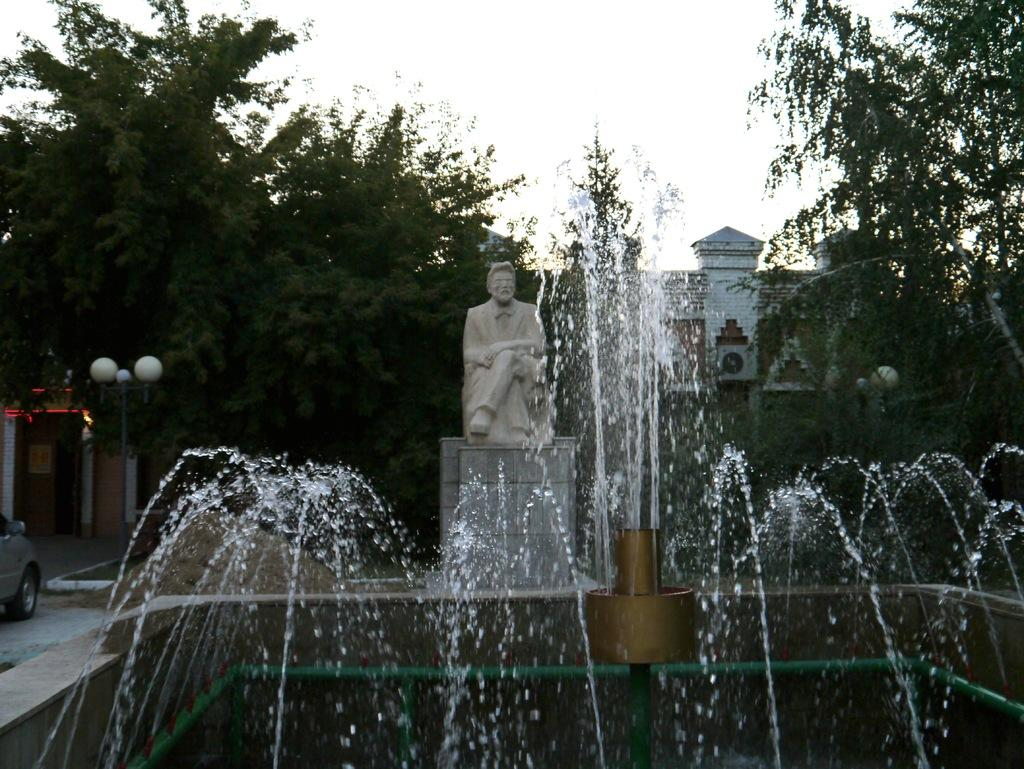What is the main feature in the image? There is a water fountain in the image. What other object is present in the image? There is a statue of a person in the image. What can be seen in the background of the image? There are trees, houses, and the sky visible in the background of the image. What type of insect is flying around the statue in the image? There is no insect present in the image; it only features a water fountain and a statue of a person. 